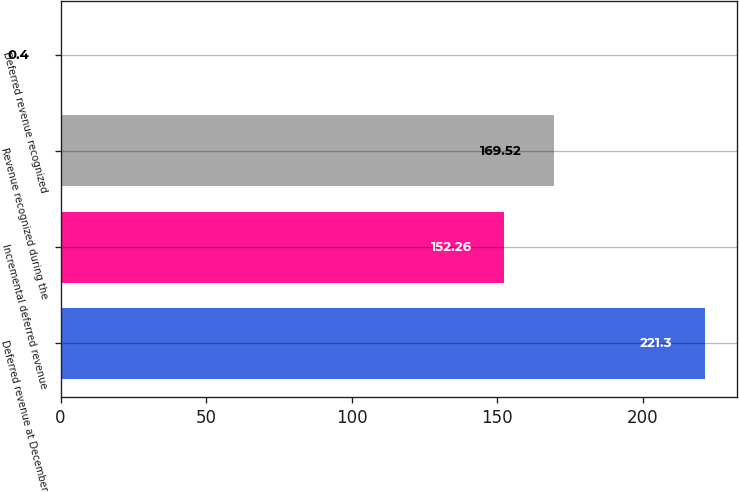Convert chart. <chart><loc_0><loc_0><loc_500><loc_500><bar_chart><fcel>Deferred revenue at December<fcel>Incremental deferred revenue<fcel>Revenue recognized during the<fcel>Deferred revenue recognized<nl><fcel>221.3<fcel>152.26<fcel>169.52<fcel>0.4<nl></chart> 